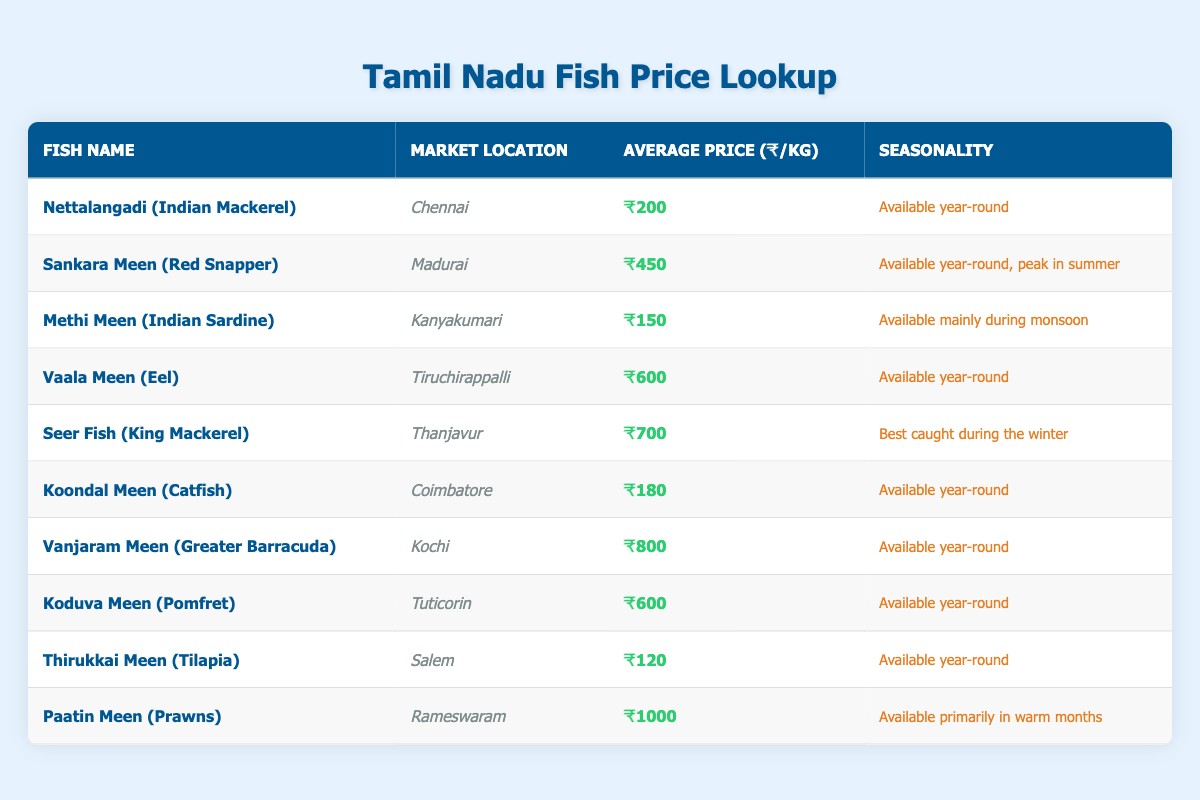What is the average price of Nettalangadi (Indian Mackerel)? The average price of Nettalangadi (Indian Mackerel) is listed as ₹200 in the table.
Answer: ₹200 Which fish is the most expensive in this table? The most expensive fish listed is Paatin Meen (Prawns) at ₹1000 per kg.
Answer: Paatin Meen (Prawns) Is Seer Fish (King Mackerel) available year-round? According to the table, Seer Fish (King Mackerel) is best caught during the winter, not available year-round.
Answer: No How much more expensive is Vanjaram Meen (Greater Barracuda) compared to Methi Meen (Indian Sardine)? Vanjaram Meen (Greater Barracuda) costs ₹800, while Methi Meen (Indian Sardine) costs ₹150. The difference is ₹800 - ₹150 = ₹650.
Answer: ₹650 In which city can I find Koondal Meen (Catfish)? The table indicates that Koondal Meen (Catfish) is available in Coimbatore.
Answer: Coimbatore What is the average price for fish available year-round? To find this, we sum the prices of all fish available year-round: ₹200 + ₹450 + ₹600 + ₹180 + ₹800 + ₹600 + ₹120 = ₹3050. There are 7 such fish, so the average price is ₹3050 / 7 = ₹435.71.
Answer: ₹435.71 Is Methi Meen (Indian Sardine) the cheapest fish in the table? The table shows that the average price of Methi Meen (Indian Sardine) is ₹150, while Thirukkai Meen (Tilapia) has a lower price of ₹120. Therefore, Methi Meen (Indian Sardine) is not the cheapest.
Answer: No Which fish is available in Kanyakumari and what is its price? The table states that Methi Meen (Indian Sardine) is available in Kanyakumari for ₹150 per kg.
Answer: Methi Meen (Indian Sardine), ₹150 How many fish are priced above ₹600 per kg? From the table, we see that only three fish are priced above ₹600 per kg: Vaala Meen (Eel) at ₹600, Seer Fish (King Mackerel) at ₹700, and Vanjaram Meen (Greater Barracuda) at ₹800. Therefore, there are three fish.
Answer: 3 